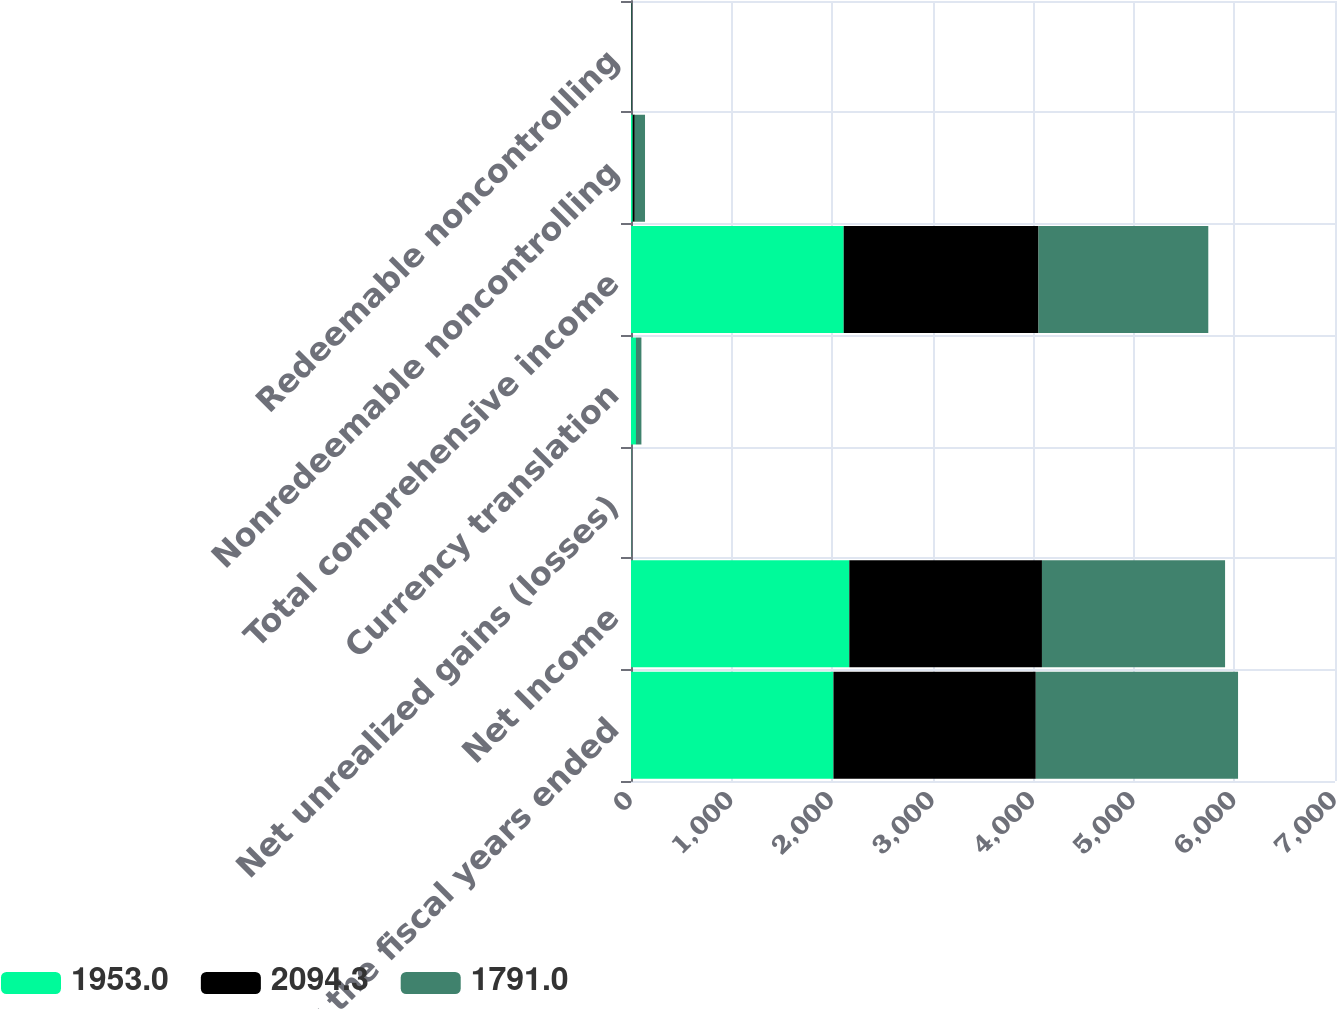Convert chart. <chart><loc_0><loc_0><loc_500><loc_500><stacked_bar_chart><ecel><fcel>for the fiscal years ended<fcel>Net Income<fcel>Net unrealized gains (losses)<fcel>Currency translation<fcel>Total comprehensive income<fcel>Nonredeemable noncontrolling<fcel>Redeemable noncontrolling<nl><fcel>1953<fcel>2013<fcel>2170.7<fcel>1.7<fcel>49.5<fcel>2114.8<fcel>16.9<fcel>3.6<nl><fcel>2094.3<fcel>2012<fcel>1915.5<fcel>0.9<fcel>0.3<fcel>1937.1<fcel>20.9<fcel>5<nl><fcel>1791<fcel>2011<fcel>1820.8<fcel>0.3<fcel>53.7<fcel>1688.2<fcel>101.6<fcel>1.2<nl></chart> 